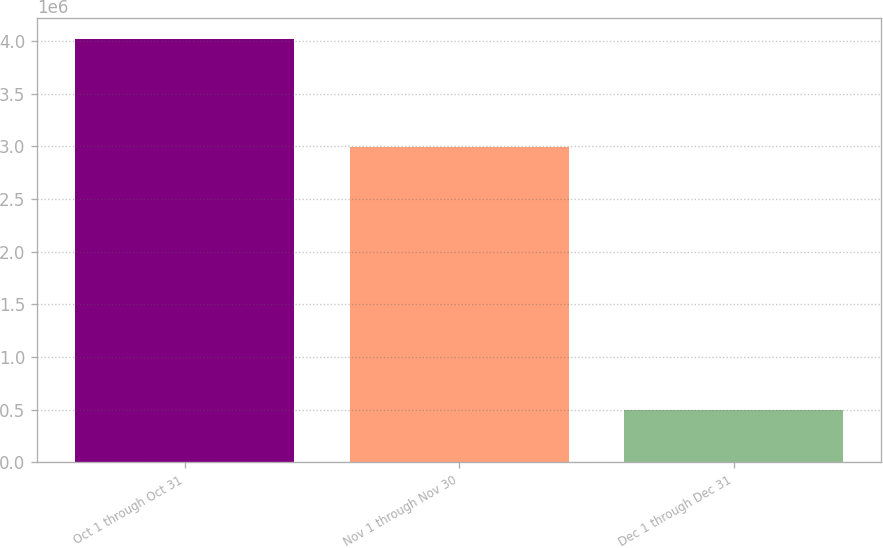Convert chart to OTSL. <chart><loc_0><loc_0><loc_500><loc_500><bar_chart><fcel>Oct 1 through Oct 31<fcel>Nov 1 through Nov 30<fcel>Dec 1 through Dec 31<nl><fcel>4.02065e+06<fcel>2.99565e+06<fcel>497130<nl></chart> 